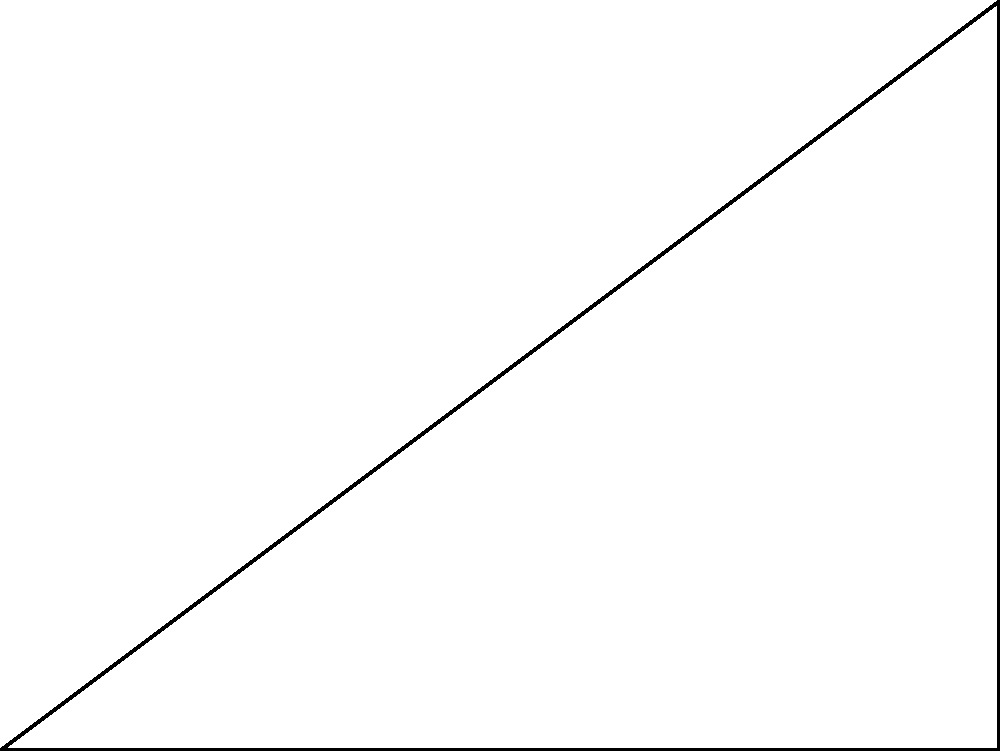In the right-angled triangle ABC shown above, given that the length of the adjacent side (AB) is 4 units and the length of the opposite side (BC) is 3 units, determine the value of $\theta$ using only the definitions of sine, cosine, and tangent. Express your answer in radians, rounded to four decimal places. To solve this problem using only the definitions of sine, cosine, and tangent, we will follow these steps:

1) Recall the definitions:
   $\sin \theta = \frac{\text{opposite}}{\text{hypotenuse}}$
   $\cos \theta = \frac{\text{adjacent}}{\text{hypotenuse}}$
   $\tan \theta = \frac{\text{opposite}}{\text{adjacent}}$

2) In this case, we know the opposite (3) and adjacent (4) sides, so it's most straightforward to use the tangent definition:

   $\tan \theta = \frac{\text{opposite}}{\text{adjacent}} = \frac{3}{4}$

3) To find $\theta$, we need to use the inverse tangent function (also known as arctangent):

   $\theta = \arctan(\frac{3}{4})$

4) Using a calculator or mathematical tables (as the original mathematicians would have), we can determine:

   $\theta \approx 0.6435$ radians (rounded to 4 decimal places)

Thus, adhering strictly to the definitions provided by the original mathematicians, we have solved for the angle $\theta$ using only the definition of tangent and its inverse function.
Answer: $0.6435$ radians 